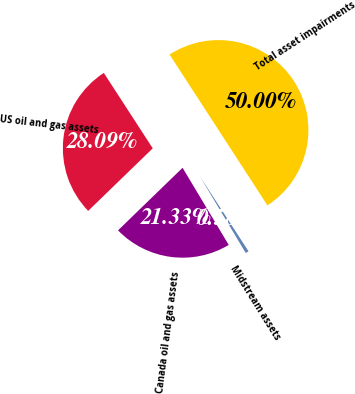Convert chart. <chart><loc_0><loc_0><loc_500><loc_500><pie_chart><fcel>US oil and gas assets<fcel>Canada oil and gas assets<fcel>Midstream assets<fcel>Total asset impairments<nl><fcel>28.09%<fcel>21.33%<fcel>0.58%<fcel>50.0%<nl></chart> 